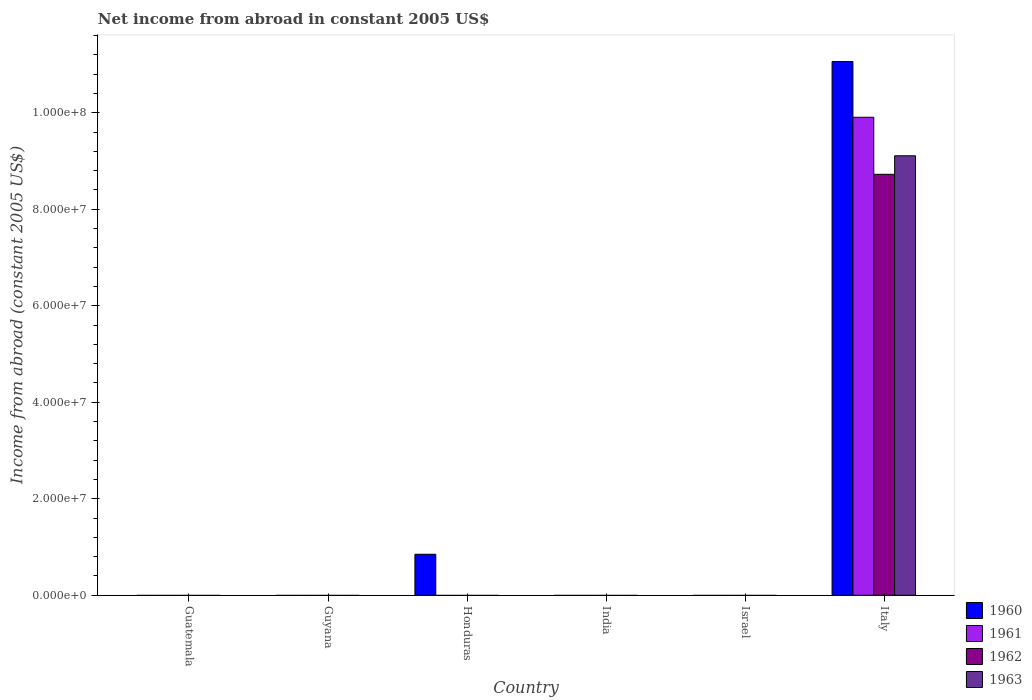How many different coloured bars are there?
Provide a short and direct response. 4. Are the number of bars per tick equal to the number of legend labels?
Your answer should be compact. No. What is the label of the 5th group of bars from the left?
Ensure brevity in your answer.  Israel. In how many cases, is the number of bars for a given country not equal to the number of legend labels?
Offer a terse response. 5. What is the net income from abroad in 1960 in Italy?
Offer a very short reply. 1.11e+08. Across all countries, what is the maximum net income from abroad in 1963?
Your answer should be very brief. 9.11e+07. Across all countries, what is the minimum net income from abroad in 1962?
Your answer should be compact. 0. In which country was the net income from abroad in 1962 maximum?
Provide a succinct answer. Italy. What is the total net income from abroad in 1962 in the graph?
Keep it short and to the point. 8.72e+07. What is the difference between the net income from abroad in 1961 in Guyana and the net income from abroad in 1963 in Israel?
Your response must be concise. 0. What is the average net income from abroad in 1963 per country?
Keep it short and to the point. 1.52e+07. What is the difference between the net income from abroad of/in 1960 and net income from abroad of/in 1961 in Italy?
Make the answer very short. 1.15e+07. In how many countries, is the net income from abroad in 1961 greater than 44000000 US$?
Offer a terse response. 1. What is the difference between the highest and the lowest net income from abroad in 1960?
Give a very brief answer. 1.11e+08. In how many countries, is the net income from abroad in 1962 greater than the average net income from abroad in 1962 taken over all countries?
Offer a very short reply. 1. What is the difference between two consecutive major ticks on the Y-axis?
Make the answer very short. 2.00e+07. Are the values on the major ticks of Y-axis written in scientific E-notation?
Your answer should be compact. Yes. Does the graph contain any zero values?
Provide a short and direct response. Yes. Where does the legend appear in the graph?
Ensure brevity in your answer.  Bottom right. What is the title of the graph?
Ensure brevity in your answer.  Net income from abroad in constant 2005 US$. What is the label or title of the X-axis?
Provide a short and direct response. Country. What is the label or title of the Y-axis?
Offer a terse response. Income from abroad (constant 2005 US$). What is the Income from abroad (constant 2005 US$) of 1962 in Guatemala?
Make the answer very short. 0. What is the Income from abroad (constant 2005 US$) of 1960 in Honduras?
Your answer should be compact. 8.50e+06. What is the Income from abroad (constant 2005 US$) in 1962 in Honduras?
Your answer should be very brief. 0. What is the Income from abroad (constant 2005 US$) of 1961 in India?
Keep it short and to the point. 0. What is the Income from abroad (constant 2005 US$) in 1963 in India?
Offer a terse response. 0. What is the Income from abroad (constant 2005 US$) in 1960 in Italy?
Give a very brief answer. 1.11e+08. What is the Income from abroad (constant 2005 US$) of 1961 in Italy?
Offer a very short reply. 9.91e+07. What is the Income from abroad (constant 2005 US$) of 1962 in Italy?
Ensure brevity in your answer.  8.72e+07. What is the Income from abroad (constant 2005 US$) of 1963 in Italy?
Your response must be concise. 9.11e+07. Across all countries, what is the maximum Income from abroad (constant 2005 US$) in 1960?
Ensure brevity in your answer.  1.11e+08. Across all countries, what is the maximum Income from abroad (constant 2005 US$) of 1961?
Offer a terse response. 9.91e+07. Across all countries, what is the maximum Income from abroad (constant 2005 US$) in 1962?
Keep it short and to the point. 8.72e+07. Across all countries, what is the maximum Income from abroad (constant 2005 US$) in 1963?
Offer a very short reply. 9.11e+07. Across all countries, what is the minimum Income from abroad (constant 2005 US$) of 1961?
Ensure brevity in your answer.  0. Across all countries, what is the minimum Income from abroad (constant 2005 US$) of 1963?
Ensure brevity in your answer.  0. What is the total Income from abroad (constant 2005 US$) of 1960 in the graph?
Your response must be concise. 1.19e+08. What is the total Income from abroad (constant 2005 US$) of 1961 in the graph?
Ensure brevity in your answer.  9.91e+07. What is the total Income from abroad (constant 2005 US$) in 1962 in the graph?
Give a very brief answer. 8.72e+07. What is the total Income from abroad (constant 2005 US$) in 1963 in the graph?
Give a very brief answer. 9.11e+07. What is the difference between the Income from abroad (constant 2005 US$) in 1960 in Honduras and that in Italy?
Give a very brief answer. -1.02e+08. What is the difference between the Income from abroad (constant 2005 US$) in 1960 in Honduras and the Income from abroad (constant 2005 US$) in 1961 in Italy?
Keep it short and to the point. -9.06e+07. What is the difference between the Income from abroad (constant 2005 US$) of 1960 in Honduras and the Income from abroad (constant 2005 US$) of 1962 in Italy?
Offer a terse response. -7.87e+07. What is the difference between the Income from abroad (constant 2005 US$) of 1960 in Honduras and the Income from abroad (constant 2005 US$) of 1963 in Italy?
Offer a terse response. -8.26e+07. What is the average Income from abroad (constant 2005 US$) in 1960 per country?
Your answer should be compact. 1.99e+07. What is the average Income from abroad (constant 2005 US$) in 1961 per country?
Offer a very short reply. 1.65e+07. What is the average Income from abroad (constant 2005 US$) of 1962 per country?
Give a very brief answer. 1.45e+07. What is the average Income from abroad (constant 2005 US$) in 1963 per country?
Provide a short and direct response. 1.52e+07. What is the difference between the Income from abroad (constant 2005 US$) of 1960 and Income from abroad (constant 2005 US$) of 1961 in Italy?
Ensure brevity in your answer.  1.15e+07. What is the difference between the Income from abroad (constant 2005 US$) in 1960 and Income from abroad (constant 2005 US$) in 1962 in Italy?
Your answer should be compact. 2.34e+07. What is the difference between the Income from abroad (constant 2005 US$) in 1960 and Income from abroad (constant 2005 US$) in 1963 in Italy?
Offer a terse response. 1.95e+07. What is the difference between the Income from abroad (constant 2005 US$) of 1961 and Income from abroad (constant 2005 US$) of 1962 in Italy?
Keep it short and to the point. 1.18e+07. What is the difference between the Income from abroad (constant 2005 US$) of 1961 and Income from abroad (constant 2005 US$) of 1963 in Italy?
Your answer should be compact. 7.98e+06. What is the difference between the Income from abroad (constant 2005 US$) in 1962 and Income from abroad (constant 2005 US$) in 1963 in Italy?
Offer a terse response. -3.84e+06. What is the ratio of the Income from abroad (constant 2005 US$) in 1960 in Honduras to that in Italy?
Your response must be concise. 0.08. What is the difference between the highest and the lowest Income from abroad (constant 2005 US$) in 1960?
Make the answer very short. 1.11e+08. What is the difference between the highest and the lowest Income from abroad (constant 2005 US$) of 1961?
Make the answer very short. 9.91e+07. What is the difference between the highest and the lowest Income from abroad (constant 2005 US$) in 1962?
Ensure brevity in your answer.  8.72e+07. What is the difference between the highest and the lowest Income from abroad (constant 2005 US$) in 1963?
Provide a short and direct response. 9.11e+07. 